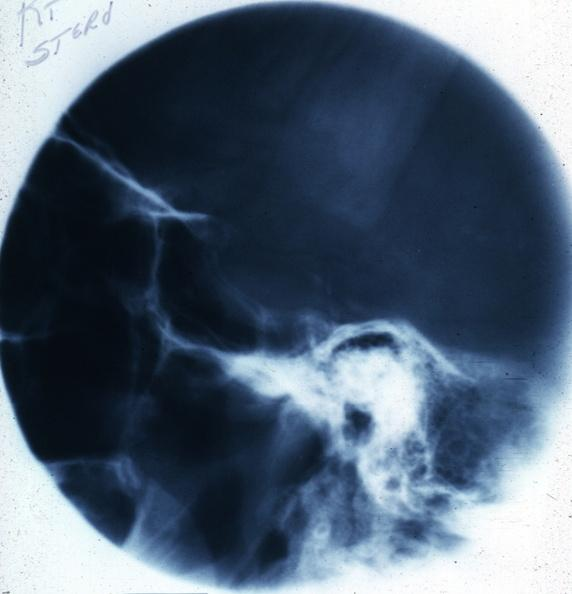does this image show x-ray sella?
Answer the question using a single word or phrase. Yes 